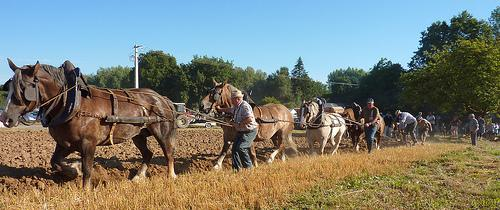Question: who took the photo?
Choices:
A. Teacher.
B. Photographer.
C. Police officer.
D. Customer.
Answer with the letter. Answer: B Question: where was the photo taken?
Choices:
A. Park.
B. Forest.
C. Beach.
D. Field.
Answer with the letter. Answer: D Question: how many types of animals are there?
Choices:
A. 1.
B. 0.
C. 2.
D. 3.
Answer with the letter. Answer: A Question: when was the photo taken?
Choices:
A. Sunset.
B. Sunrise.
C. Evening.
D. Afternoon.
Answer with the letter. Answer: D Question: what color is first horse?
Choices:
A. Black.
B. White.
C. Gray.
D. Brown.
Answer with the letter. Answer: D 